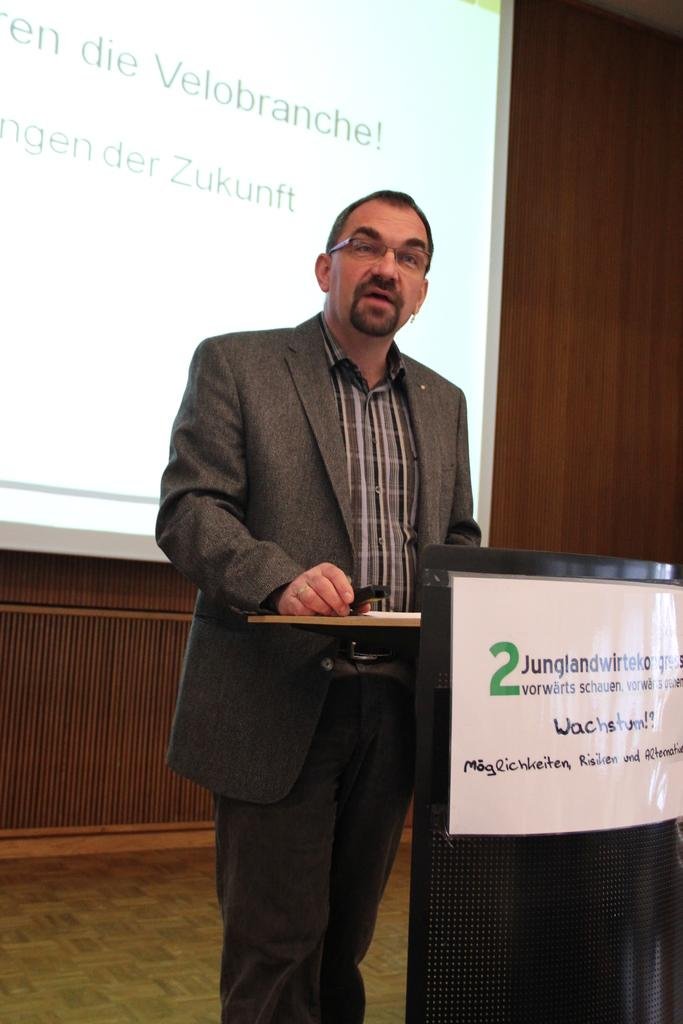Who is present in the image? There is a man in the image. What can be seen on the wall in the image? There is a poster in the image. What is the purpose of the screen in the image? The purpose of the screen in the image is not specified, but it could be a TV, computer, or monitor. What type of punishment is being administered to the man in the image? There is no indication of punishment in the image; it only shows a man, a poster, and a screen. 